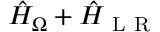<formula> <loc_0><loc_0><loc_500><loc_500>\hat { H } _ { \Omega } + \hat { H } _ { L R }</formula> 